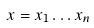<formula> <loc_0><loc_0><loc_500><loc_500>x = x _ { 1 } \dots x _ { n }</formula> 